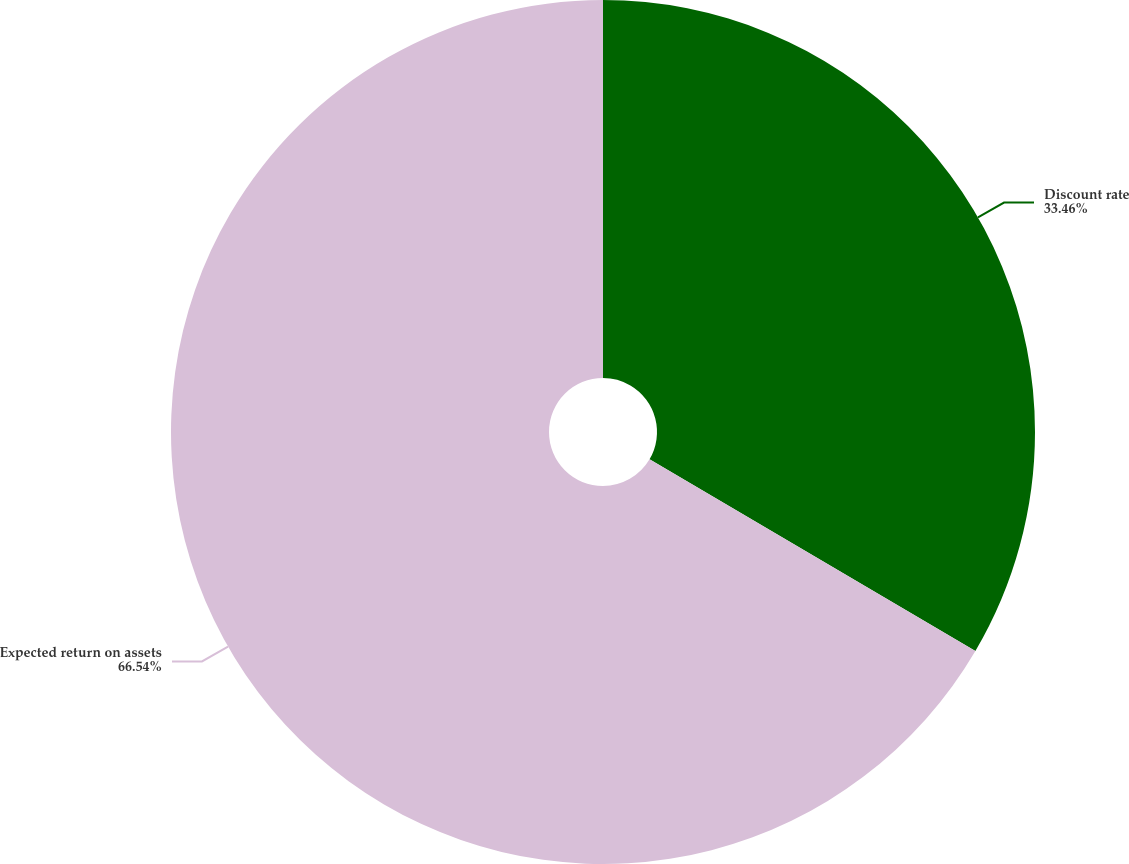Convert chart. <chart><loc_0><loc_0><loc_500><loc_500><pie_chart><fcel>Discount rate<fcel>Expected return on assets<nl><fcel>33.46%<fcel>66.54%<nl></chart> 